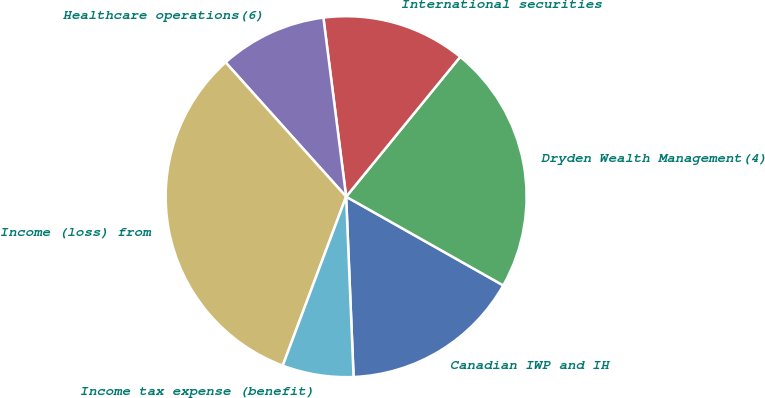<chart> <loc_0><loc_0><loc_500><loc_500><pie_chart><fcel>Canadian IWP and IH<fcel>Dryden Wealth Management(4)<fcel>International securities<fcel>Healthcare operations(6)<fcel>Income (loss) from<fcel>Income tax expense (benefit)<nl><fcel>16.16%<fcel>22.29%<fcel>12.9%<fcel>9.63%<fcel>32.64%<fcel>6.37%<nl></chart> 